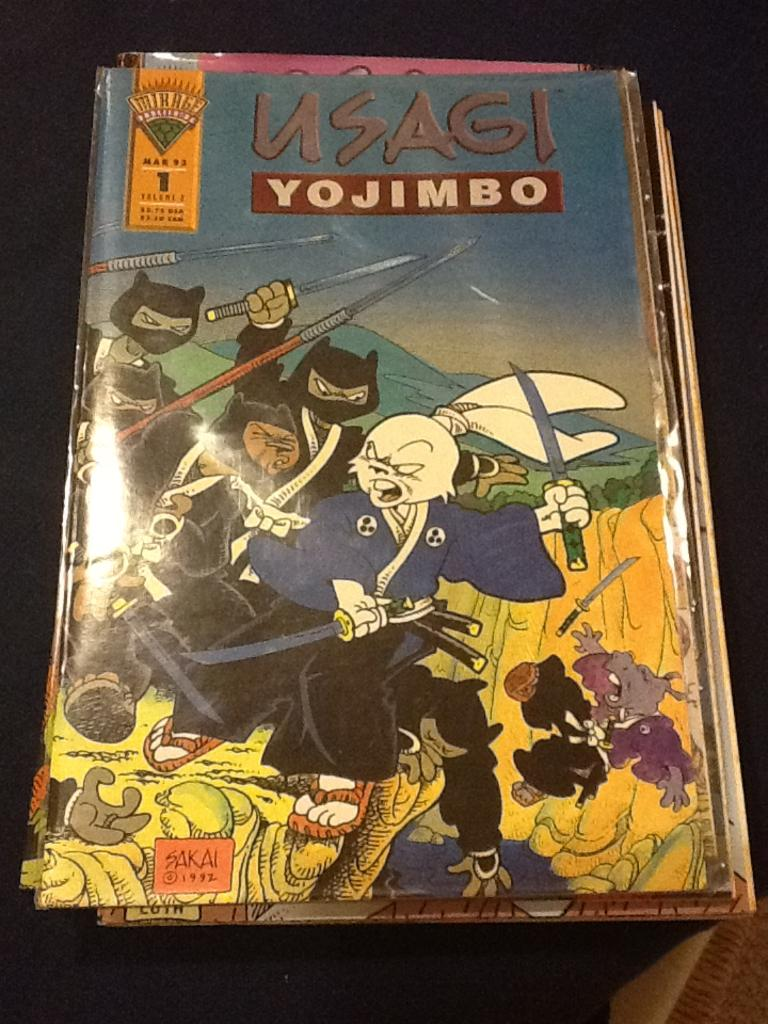<image>
Summarize the visual content of the image. A stack of Usagi comics rest on a table. 